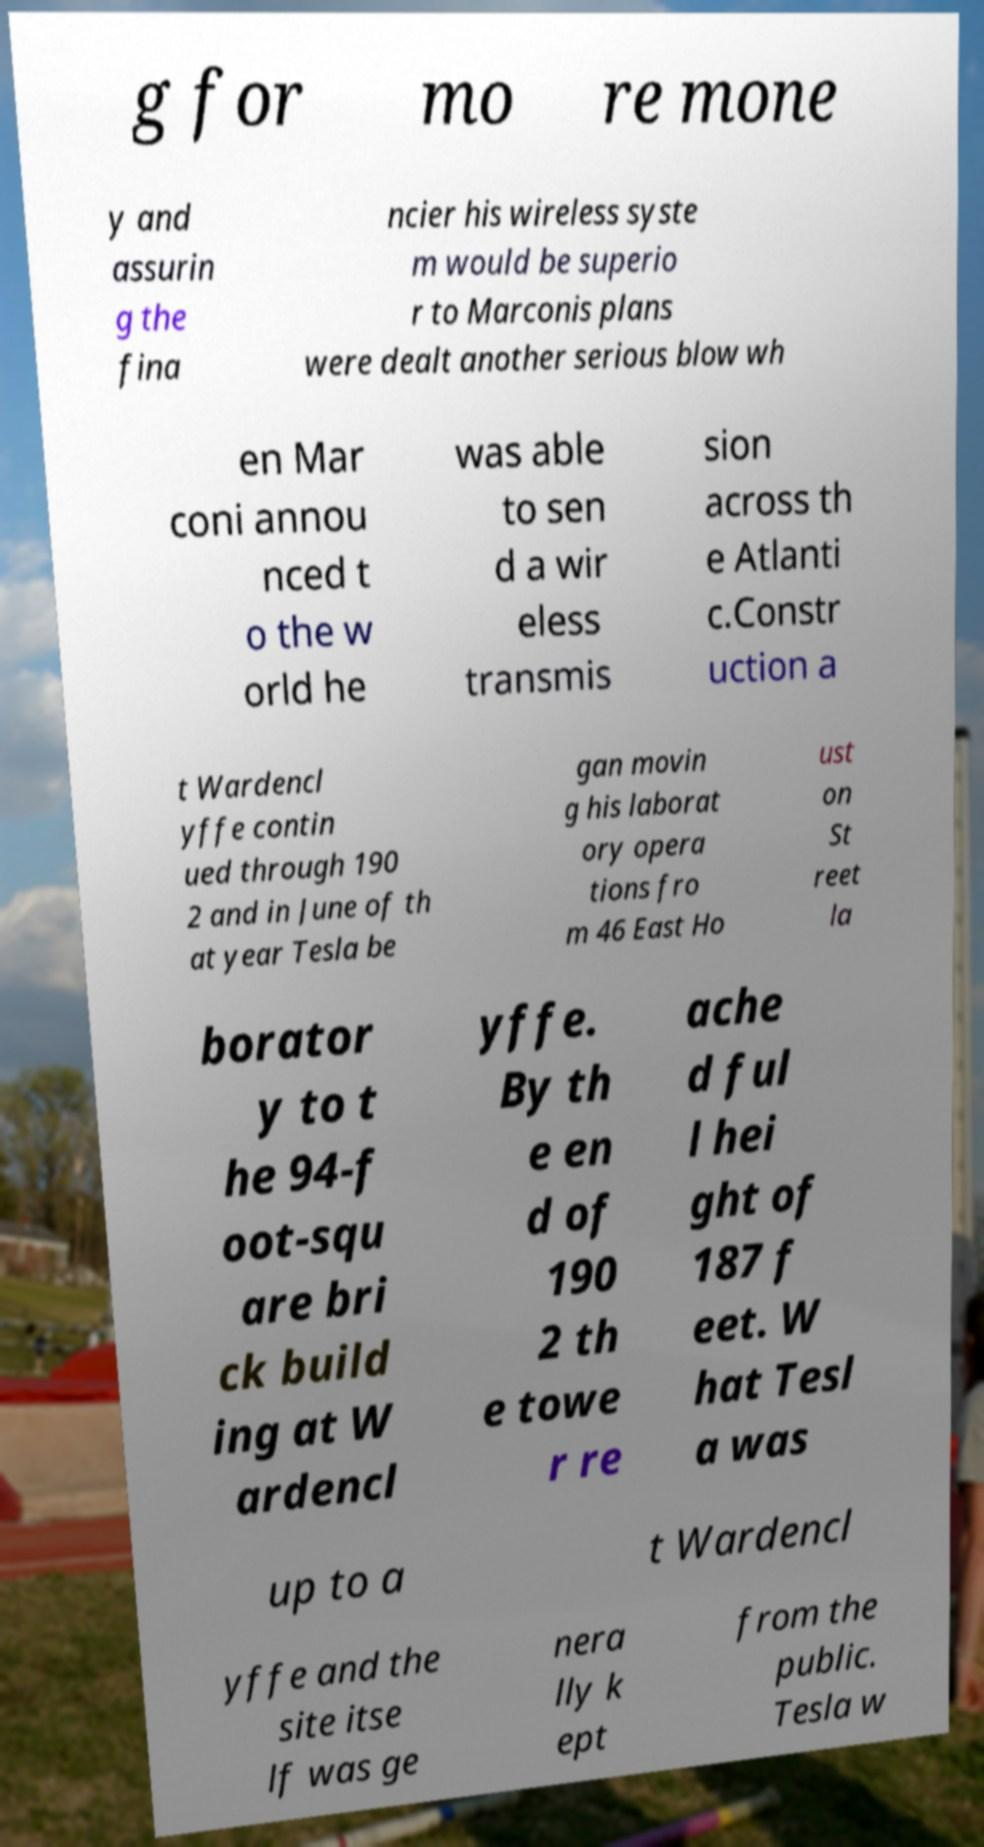There's text embedded in this image that I need extracted. Can you transcribe it verbatim? g for mo re mone y and assurin g the fina ncier his wireless syste m would be superio r to Marconis plans were dealt another serious blow wh en Mar coni annou nced t o the w orld he was able to sen d a wir eless transmis sion across th e Atlanti c.Constr uction a t Wardencl yffe contin ued through 190 2 and in June of th at year Tesla be gan movin g his laborat ory opera tions fro m 46 East Ho ust on St reet la borator y to t he 94-f oot-squ are bri ck build ing at W ardencl yffe. By th e en d of 190 2 th e towe r re ache d ful l hei ght of 187 f eet. W hat Tesl a was up to a t Wardencl yffe and the site itse lf was ge nera lly k ept from the public. Tesla w 